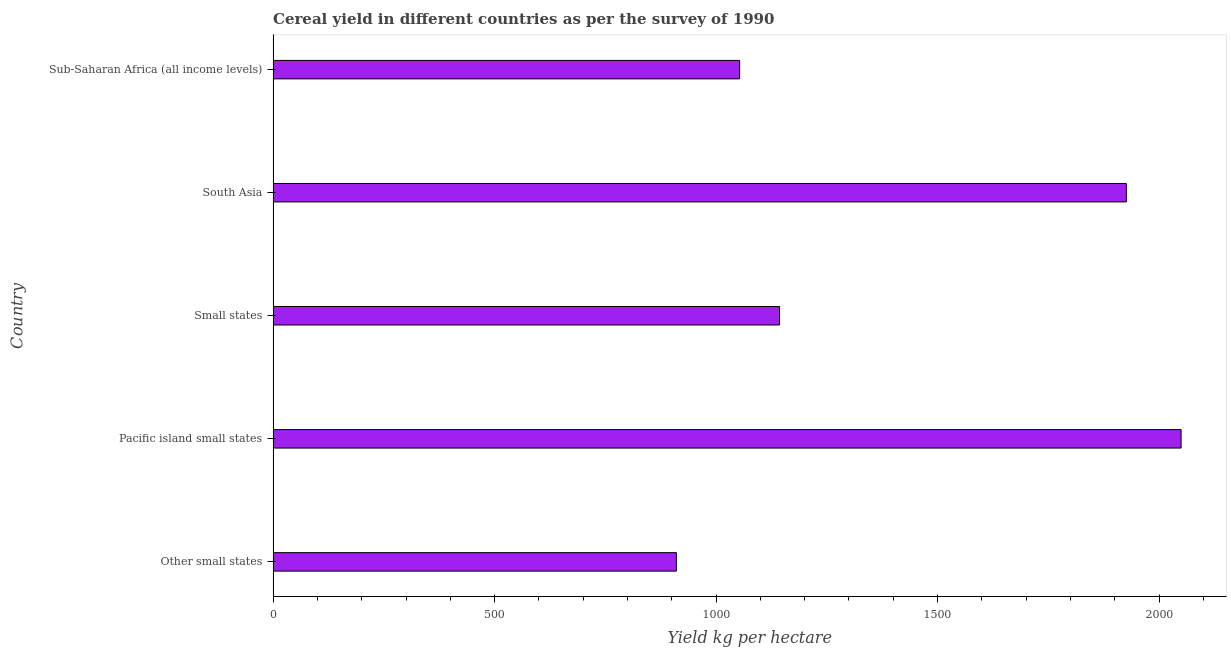Does the graph contain any zero values?
Make the answer very short. No. Does the graph contain grids?
Keep it short and to the point. No. What is the title of the graph?
Give a very brief answer. Cereal yield in different countries as per the survey of 1990. What is the label or title of the X-axis?
Give a very brief answer. Yield kg per hectare. What is the label or title of the Y-axis?
Give a very brief answer. Country. What is the cereal yield in Sub-Saharan Africa (all income levels)?
Provide a succinct answer. 1053.16. Across all countries, what is the maximum cereal yield?
Provide a succinct answer. 2049.71. Across all countries, what is the minimum cereal yield?
Offer a terse response. 910.35. In which country was the cereal yield maximum?
Your response must be concise. Pacific island small states. In which country was the cereal yield minimum?
Your response must be concise. Other small states. What is the sum of the cereal yield?
Offer a very short reply. 7082.63. What is the difference between the cereal yield in Other small states and Sub-Saharan Africa (all income levels)?
Offer a very short reply. -142.81. What is the average cereal yield per country?
Provide a short and direct response. 1416.53. What is the median cereal yield?
Make the answer very short. 1143.25. In how many countries, is the cereal yield greater than 1800 kg per hectare?
Provide a short and direct response. 2. What is the ratio of the cereal yield in South Asia to that in Sub-Saharan Africa (all income levels)?
Keep it short and to the point. 1.83. Is the cereal yield in Pacific island small states less than that in Small states?
Offer a terse response. No. Is the difference between the cereal yield in Pacific island small states and South Asia greater than the difference between any two countries?
Provide a short and direct response. No. What is the difference between the highest and the second highest cereal yield?
Make the answer very short. 123.55. Is the sum of the cereal yield in Other small states and Sub-Saharan Africa (all income levels) greater than the maximum cereal yield across all countries?
Your answer should be compact. No. What is the difference between the highest and the lowest cereal yield?
Your response must be concise. 1139.36. In how many countries, is the cereal yield greater than the average cereal yield taken over all countries?
Your answer should be compact. 2. How many countries are there in the graph?
Ensure brevity in your answer.  5. Are the values on the major ticks of X-axis written in scientific E-notation?
Give a very brief answer. No. What is the Yield kg per hectare of Other small states?
Provide a short and direct response. 910.35. What is the Yield kg per hectare of Pacific island small states?
Keep it short and to the point. 2049.71. What is the Yield kg per hectare in Small states?
Provide a short and direct response. 1143.25. What is the Yield kg per hectare in South Asia?
Offer a very short reply. 1926.16. What is the Yield kg per hectare in Sub-Saharan Africa (all income levels)?
Ensure brevity in your answer.  1053.16. What is the difference between the Yield kg per hectare in Other small states and Pacific island small states?
Ensure brevity in your answer.  -1139.36. What is the difference between the Yield kg per hectare in Other small states and Small states?
Keep it short and to the point. -232.9. What is the difference between the Yield kg per hectare in Other small states and South Asia?
Keep it short and to the point. -1015.81. What is the difference between the Yield kg per hectare in Other small states and Sub-Saharan Africa (all income levels)?
Give a very brief answer. -142.81. What is the difference between the Yield kg per hectare in Pacific island small states and Small states?
Ensure brevity in your answer.  906.46. What is the difference between the Yield kg per hectare in Pacific island small states and South Asia?
Provide a short and direct response. 123.55. What is the difference between the Yield kg per hectare in Pacific island small states and Sub-Saharan Africa (all income levels)?
Provide a succinct answer. 996.54. What is the difference between the Yield kg per hectare in Small states and South Asia?
Your response must be concise. -782.91. What is the difference between the Yield kg per hectare in Small states and Sub-Saharan Africa (all income levels)?
Ensure brevity in your answer.  90.09. What is the difference between the Yield kg per hectare in South Asia and Sub-Saharan Africa (all income levels)?
Make the answer very short. 872.99. What is the ratio of the Yield kg per hectare in Other small states to that in Pacific island small states?
Offer a terse response. 0.44. What is the ratio of the Yield kg per hectare in Other small states to that in Small states?
Provide a short and direct response. 0.8. What is the ratio of the Yield kg per hectare in Other small states to that in South Asia?
Make the answer very short. 0.47. What is the ratio of the Yield kg per hectare in Other small states to that in Sub-Saharan Africa (all income levels)?
Your answer should be compact. 0.86. What is the ratio of the Yield kg per hectare in Pacific island small states to that in Small states?
Offer a terse response. 1.79. What is the ratio of the Yield kg per hectare in Pacific island small states to that in South Asia?
Keep it short and to the point. 1.06. What is the ratio of the Yield kg per hectare in Pacific island small states to that in Sub-Saharan Africa (all income levels)?
Your answer should be compact. 1.95. What is the ratio of the Yield kg per hectare in Small states to that in South Asia?
Provide a short and direct response. 0.59. What is the ratio of the Yield kg per hectare in Small states to that in Sub-Saharan Africa (all income levels)?
Ensure brevity in your answer.  1.09. What is the ratio of the Yield kg per hectare in South Asia to that in Sub-Saharan Africa (all income levels)?
Your answer should be very brief. 1.83. 